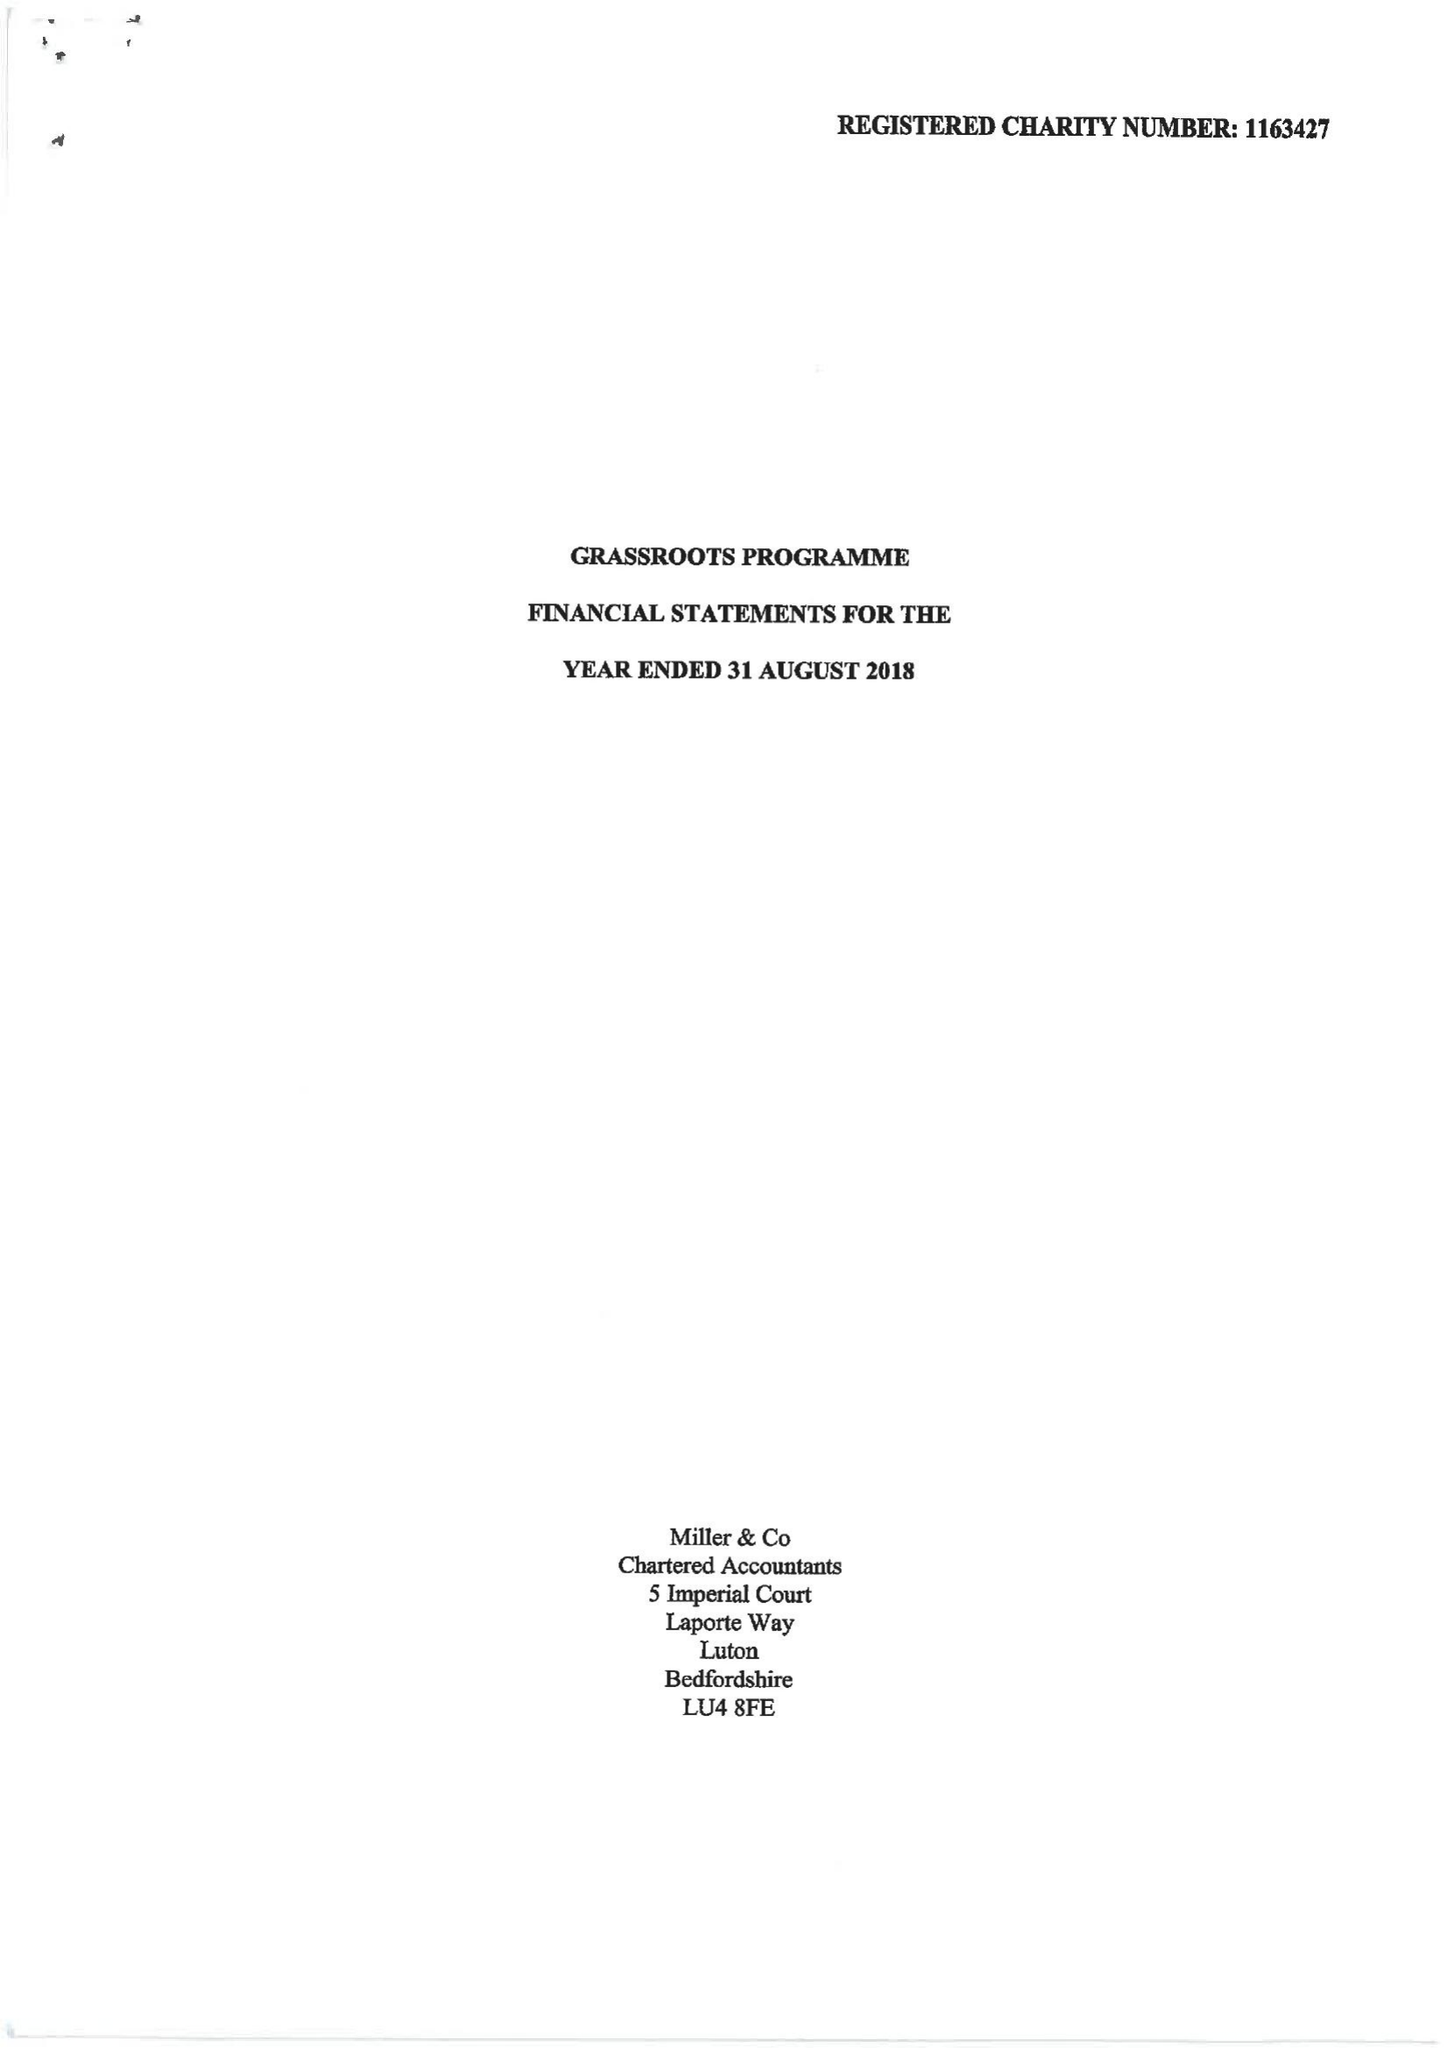What is the value for the address__street_line?
Answer the question using a single word or phrase. 47 HIGH TOWN ROAD 